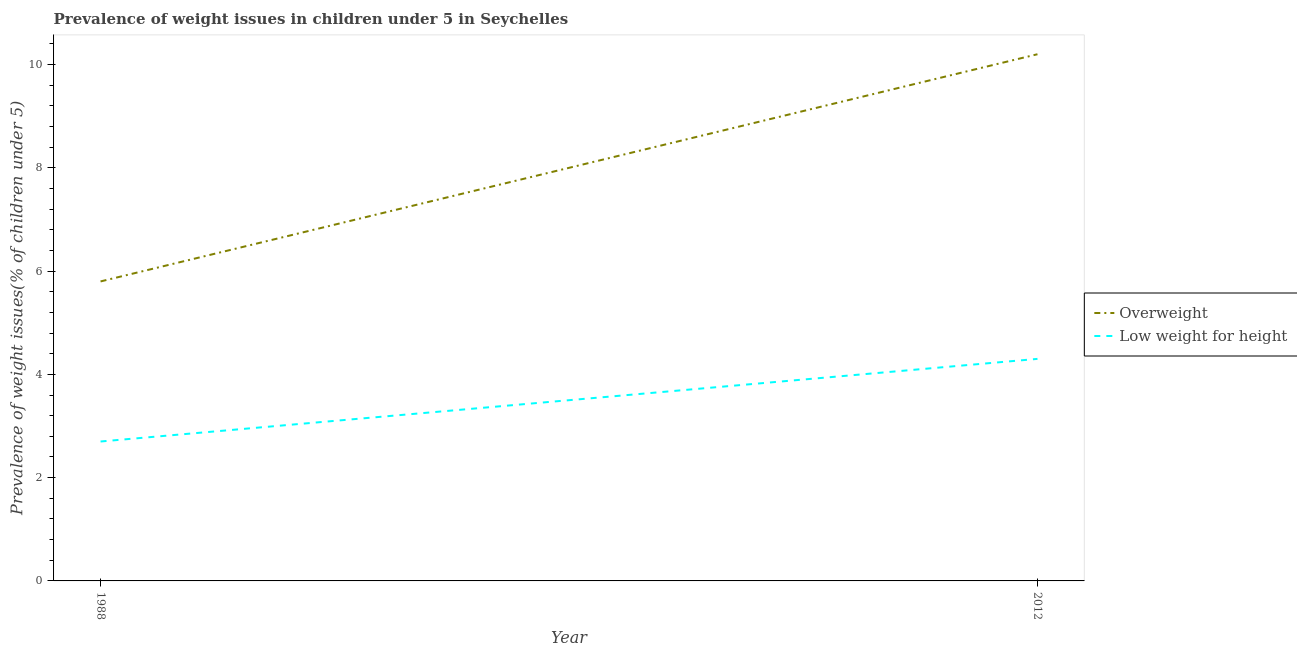How many different coloured lines are there?
Keep it short and to the point. 2. Is the number of lines equal to the number of legend labels?
Your response must be concise. Yes. What is the percentage of underweight children in 2012?
Offer a terse response. 4.3. Across all years, what is the maximum percentage of underweight children?
Provide a short and direct response. 4.3. Across all years, what is the minimum percentage of underweight children?
Give a very brief answer. 2.7. In which year was the percentage of overweight children minimum?
Give a very brief answer. 1988. What is the total percentage of overweight children in the graph?
Make the answer very short. 16. What is the difference between the percentage of overweight children in 1988 and that in 2012?
Provide a succinct answer. -4.4. What is the difference between the percentage of underweight children in 1988 and the percentage of overweight children in 2012?
Offer a terse response. -7.5. What is the average percentage of underweight children per year?
Give a very brief answer. 3.5. In the year 2012, what is the difference between the percentage of underweight children and percentage of overweight children?
Ensure brevity in your answer.  -5.9. In how many years, is the percentage of underweight children greater than 0.4 %?
Give a very brief answer. 2. What is the ratio of the percentage of underweight children in 1988 to that in 2012?
Your answer should be compact. 0.63. Is the percentage of underweight children in 1988 less than that in 2012?
Provide a short and direct response. Yes. In how many years, is the percentage of underweight children greater than the average percentage of underweight children taken over all years?
Your answer should be compact. 1. Does the percentage of underweight children monotonically increase over the years?
Keep it short and to the point. Yes. Is the percentage of overweight children strictly less than the percentage of underweight children over the years?
Your response must be concise. No. Does the graph contain any zero values?
Your response must be concise. No. Does the graph contain grids?
Give a very brief answer. No. What is the title of the graph?
Your response must be concise. Prevalence of weight issues in children under 5 in Seychelles. Does "Rural" appear as one of the legend labels in the graph?
Provide a succinct answer. No. What is the label or title of the X-axis?
Your answer should be compact. Year. What is the label or title of the Y-axis?
Give a very brief answer. Prevalence of weight issues(% of children under 5). What is the Prevalence of weight issues(% of children under 5) of Overweight in 1988?
Give a very brief answer. 5.8. What is the Prevalence of weight issues(% of children under 5) in Low weight for height in 1988?
Your answer should be very brief. 2.7. What is the Prevalence of weight issues(% of children under 5) in Overweight in 2012?
Make the answer very short. 10.2. What is the Prevalence of weight issues(% of children under 5) of Low weight for height in 2012?
Ensure brevity in your answer.  4.3. Across all years, what is the maximum Prevalence of weight issues(% of children under 5) of Overweight?
Your answer should be compact. 10.2. Across all years, what is the maximum Prevalence of weight issues(% of children under 5) in Low weight for height?
Your answer should be compact. 4.3. Across all years, what is the minimum Prevalence of weight issues(% of children under 5) of Overweight?
Make the answer very short. 5.8. Across all years, what is the minimum Prevalence of weight issues(% of children under 5) in Low weight for height?
Offer a very short reply. 2.7. What is the total Prevalence of weight issues(% of children under 5) of Overweight in the graph?
Provide a succinct answer. 16. What is the difference between the Prevalence of weight issues(% of children under 5) in Overweight in 1988 and that in 2012?
Make the answer very short. -4.4. What is the difference between the Prevalence of weight issues(% of children under 5) of Low weight for height in 1988 and that in 2012?
Your response must be concise. -1.6. What is the average Prevalence of weight issues(% of children under 5) of Overweight per year?
Your answer should be very brief. 8. What is the average Prevalence of weight issues(% of children under 5) in Low weight for height per year?
Your response must be concise. 3.5. In the year 1988, what is the difference between the Prevalence of weight issues(% of children under 5) in Overweight and Prevalence of weight issues(% of children under 5) in Low weight for height?
Offer a terse response. 3.1. What is the ratio of the Prevalence of weight issues(% of children under 5) of Overweight in 1988 to that in 2012?
Ensure brevity in your answer.  0.57. What is the ratio of the Prevalence of weight issues(% of children under 5) in Low weight for height in 1988 to that in 2012?
Your answer should be very brief. 0.63. What is the difference between the highest and the second highest Prevalence of weight issues(% of children under 5) of Overweight?
Ensure brevity in your answer.  4.4. What is the difference between the highest and the lowest Prevalence of weight issues(% of children under 5) in Overweight?
Ensure brevity in your answer.  4.4. 